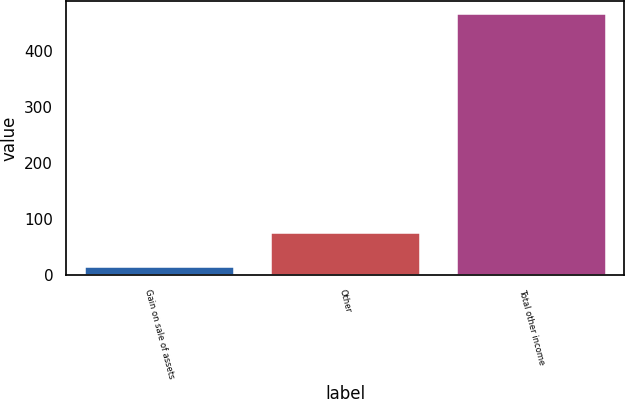<chart> <loc_0><loc_0><loc_500><loc_500><bar_chart><fcel>Gain on sale of assets<fcel>Other<fcel>Total other income<nl><fcel>14<fcel>74<fcel>465<nl></chart> 